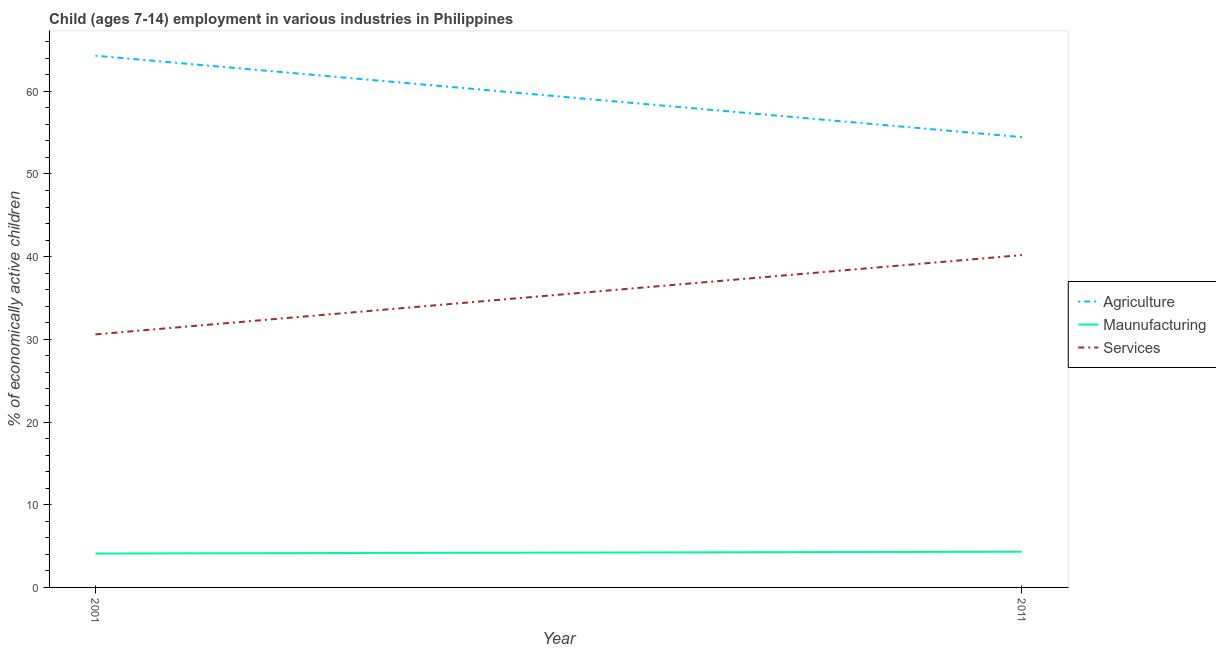How many different coloured lines are there?
Give a very brief answer. 3. Does the line corresponding to percentage of economically active children in manufacturing intersect with the line corresponding to percentage of economically active children in services?
Your answer should be compact. No. Is the number of lines equal to the number of legend labels?
Make the answer very short. Yes. What is the percentage of economically active children in agriculture in 2011?
Provide a short and direct response. 54.45. Across all years, what is the maximum percentage of economically active children in agriculture?
Your answer should be compact. 64.3. Across all years, what is the minimum percentage of economically active children in services?
Give a very brief answer. 30.6. In which year was the percentage of economically active children in services minimum?
Keep it short and to the point. 2001. What is the total percentage of economically active children in manufacturing in the graph?
Ensure brevity in your answer.  8.42. What is the difference between the percentage of economically active children in manufacturing in 2001 and that in 2011?
Provide a succinct answer. -0.22. What is the difference between the percentage of economically active children in agriculture in 2011 and the percentage of economically active children in services in 2001?
Provide a short and direct response. 23.85. What is the average percentage of economically active children in manufacturing per year?
Offer a very short reply. 4.21. In the year 2011, what is the difference between the percentage of economically active children in manufacturing and percentage of economically active children in services?
Ensure brevity in your answer.  -35.87. What is the ratio of the percentage of economically active children in manufacturing in 2001 to that in 2011?
Give a very brief answer. 0.95. Is the percentage of economically active children in agriculture in 2001 less than that in 2011?
Your answer should be very brief. No. In how many years, is the percentage of economically active children in agriculture greater than the average percentage of economically active children in agriculture taken over all years?
Your answer should be very brief. 1. Does the percentage of economically active children in manufacturing monotonically increase over the years?
Give a very brief answer. Yes. Is the percentage of economically active children in services strictly less than the percentage of economically active children in manufacturing over the years?
Your answer should be compact. No. How many lines are there?
Provide a succinct answer. 3. How many years are there in the graph?
Offer a terse response. 2. How are the legend labels stacked?
Your answer should be very brief. Vertical. What is the title of the graph?
Your answer should be compact. Child (ages 7-14) employment in various industries in Philippines. What is the label or title of the Y-axis?
Make the answer very short. % of economically active children. What is the % of economically active children in Agriculture in 2001?
Offer a very short reply. 64.3. What is the % of economically active children in Services in 2001?
Make the answer very short. 30.6. What is the % of economically active children of Agriculture in 2011?
Your response must be concise. 54.45. What is the % of economically active children of Maunufacturing in 2011?
Provide a short and direct response. 4.32. What is the % of economically active children of Services in 2011?
Make the answer very short. 40.19. Across all years, what is the maximum % of economically active children in Agriculture?
Your response must be concise. 64.3. Across all years, what is the maximum % of economically active children in Maunufacturing?
Keep it short and to the point. 4.32. Across all years, what is the maximum % of economically active children in Services?
Keep it short and to the point. 40.19. Across all years, what is the minimum % of economically active children of Agriculture?
Give a very brief answer. 54.45. Across all years, what is the minimum % of economically active children in Maunufacturing?
Give a very brief answer. 4.1. Across all years, what is the minimum % of economically active children in Services?
Keep it short and to the point. 30.6. What is the total % of economically active children of Agriculture in the graph?
Offer a very short reply. 118.75. What is the total % of economically active children in Maunufacturing in the graph?
Your answer should be very brief. 8.42. What is the total % of economically active children in Services in the graph?
Your response must be concise. 70.79. What is the difference between the % of economically active children in Agriculture in 2001 and that in 2011?
Give a very brief answer. 9.85. What is the difference between the % of economically active children of Maunufacturing in 2001 and that in 2011?
Make the answer very short. -0.22. What is the difference between the % of economically active children in Services in 2001 and that in 2011?
Your answer should be compact. -9.59. What is the difference between the % of economically active children of Agriculture in 2001 and the % of economically active children of Maunufacturing in 2011?
Your answer should be compact. 59.98. What is the difference between the % of economically active children of Agriculture in 2001 and the % of economically active children of Services in 2011?
Provide a short and direct response. 24.11. What is the difference between the % of economically active children in Maunufacturing in 2001 and the % of economically active children in Services in 2011?
Your answer should be compact. -36.09. What is the average % of economically active children in Agriculture per year?
Keep it short and to the point. 59.38. What is the average % of economically active children in Maunufacturing per year?
Your answer should be very brief. 4.21. What is the average % of economically active children of Services per year?
Ensure brevity in your answer.  35.4. In the year 2001, what is the difference between the % of economically active children of Agriculture and % of economically active children of Maunufacturing?
Make the answer very short. 60.2. In the year 2001, what is the difference between the % of economically active children in Agriculture and % of economically active children in Services?
Make the answer very short. 33.7. In the year 2001, what is the difference between the % of economically active children in Maunufacturing and % of economically active children in Services?
Ensure brevity in your answer.  -26.5. In the year 2011, what is the difference between the % of economically active children in Agriculture and % of economically active children in Maunufacturing?
Offer a very short reply. 50.13. In the year 2011, what is the difference between the % of economically active children in Agriculture and % of economically active children in Services?
Your answer should be very brief. 14.26. In the year 2011, what is the difference between the % of economically active children in Maunufacturing and % of economically active children in Services?
Your response must be concise. -35.87. What is the ratio of the % of economically active children in Agriculture in 2001 to that in 2011?
Provide a succinct answer. 1.18. What is the ratio of the % of economically active children of Maunufacturing in 2001 to that in 2011?
Offer a very short reply. 0.95. What is the ratio of the % of economically active children of Services in 2001 to that in 2011?
Make the answer very short. 0.76. What is the difference between the highest and the second highest % of economically active children of Agriculture?
Provide a succinct answer. 9.85. What is the difference between the highest and the second highest % of economically active children in Maunufacturing?
Keep it short and to the point. 0.22. What is the difference between the highest and the second highest % of economically active children in Services?
Your response must be concise. 9.59. What is the difference between the highest and the lowest % of economically active children in Agriculture?
Offer a very short reply. 9.85. What is the difference between the highest and the lowest % of economically active children of Maunufacturing?
Your answer should be compact. 0.22. What is the difference between the highest and the lowest % of economically active children of Services?
Your answer should be compact. 9.59. 